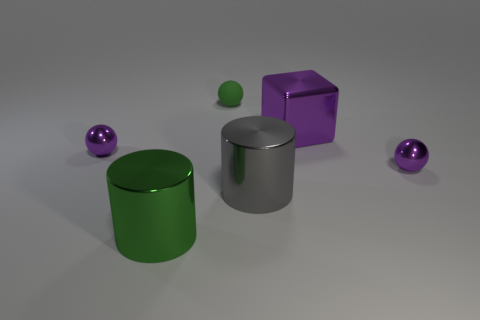How many purple things are on the right side of the big green thing?
Your answer should be very brief. 2. Do the cube and the tiny green thing that is left of the big gray object have the same material?
Make the answer very short. No. Are there any green cylinders that have the same size as the rubber thing?
Make the answer very short. No. Are there an equal number of green balls on the right side of the tiny green matte object and big cylinders?
Give a very brief answer. No. The gray thing is what size?
Provide a succinct answer. Large. What number of big gray cylinders are on the right side of the purple thing that is left of the big metal cube?
Your answer should be compact. 1. There is a small object that is both on the right side of the large green cylinder and in front of the green matte sphere; what shape is it?
Your answer should be compact. Sphere. How many objects are the same color as the metal block?
Offer a very short reply. 2. There is a green object that is behind the small purple metal object that is on the right side of the purple metallic block; is there a large cylinder that is in front of it?
Offer a very short reply. Yes. What size is the ball that is both left of the purple cube and in front of the large purple metallic thing?
Provide a short and direct response. Small. 